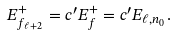<formula> <loc_0><loc_0><loc_500><loc_500>E _ { f _ { \ell + 2 } } ^ { + } = c ^ { \prime } E _ { f } ^ { + } = c ^ { \prime } E _ { \ell , n _ { 0 } } .</formula> 